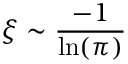<formula> <loc_0><loc_0><loc_500><loc_500>\xi \sim \frac { - 1 } { \ln ( \pi ) }</formula> 